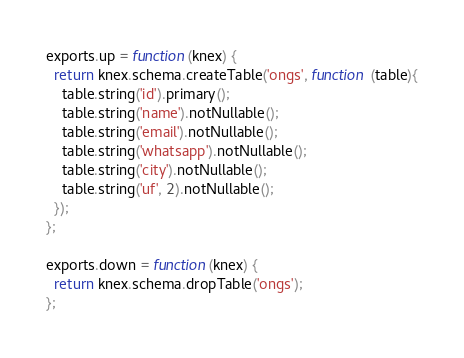<code> <loc_0><loc_0><loc_500><loc_500><_JavaScript_>exports.up = function(knex) {
  return knex.schema.createTable('ongs', function (table){
    table.string('id').primary();
    table.string('name').notNullable();
    table.string('email').notNullable();
    table.string('whatsapp').notNullable();
    table.string('city').notNullable();
    table.string('uf', 2).notNullable();
  });
};

exports.down = function(knex) {
  return knex.schema.dropTable('ongs');
};</code> 